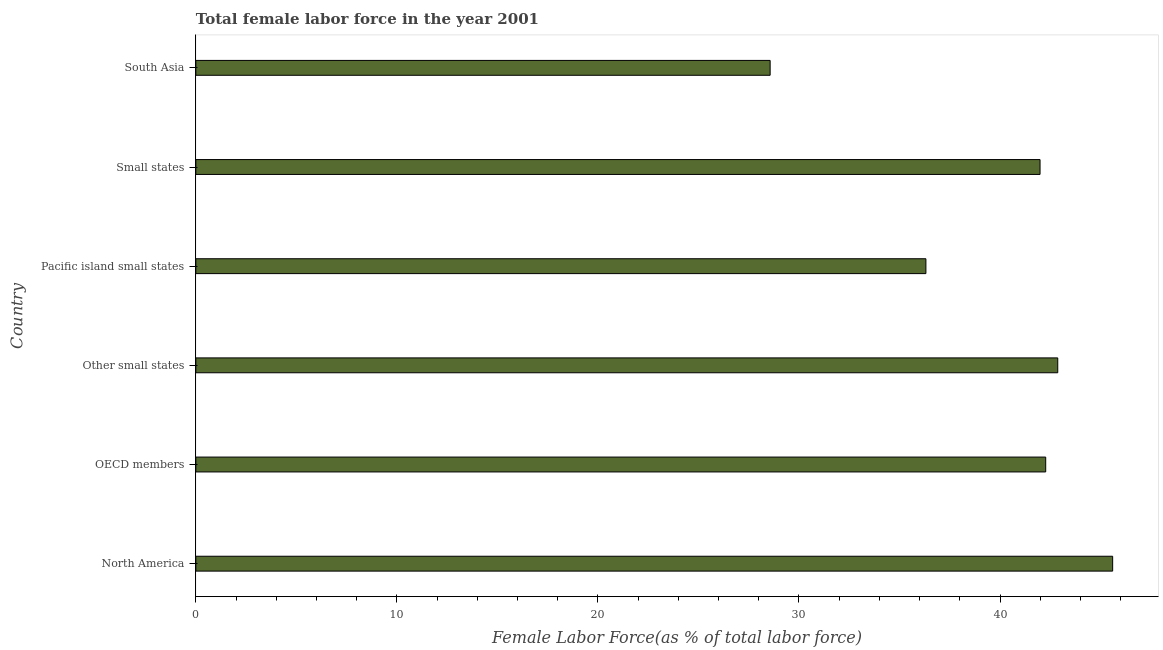Does the graph contain any zero values?
Make the answer very short. No. Does the graph contain grids?
Give a very brief answer. No. What is the title of the graph?
Ensure brevity in your answer.  Total female labor force in the year 2001. What is the label or title of the X-axis?
Offer a terse response. Female Labor Force(as % of total labor force). What is the label or title of the Y-axis?
Offer a terse response. Country. What is the total female labor force in Small states?
Offer a very short reply. 41.99. Across all countries, what is the maximum total female labor force?
Give a very brief answer. 45.6. Across all countries, what is the minimum total female labor force?
Offer a terse response. 28.57. In which country was the total female labor force maximum?
Offer a terse response. North America. What is the sum of the total female labor force?
Offer a very short reply. 237.61. What is the difference between the total female labor force in Other small states and Small states?
Make the answer very short. 0.88. What is the average total female labor force per country?
Make the answer very short. 39.6. What is the median total female labor force?
Your answer should be very brief. 42.13. In how many countries, is the total female labor force greater than 10 %?
Offer a terse response. 6. What is the ratio of the total female labor force in OECD members to that in Pacific island small states?
Provide a succinct answer. 1.16. Is the difference between the total female labor force in Small states and South Asia greater than the difference between any two countries?
Offer a terse response. No. What is the difference between the highest and the second highest total female labor force?
Provide a short and direct response. 2.73. What is the difference between the highest and the lowest total female labor force?
Your response must be concise. 17.04. In how many countries, is the total female labor force greater than the average total female labor force taken over all countries?
Your response must be concise. 4. How many bars are there?
Your answer should be very brief. 6. Are all the bars in the graph horizontal?
Offer a terse response. Yes. What is the difference between two consecutive major ticks on the X-axis?
Your answer should be very brief. 10. What is the Female Labor Force(as % of total labor force) in North America?
Keep it short and to the point. 45.6. What is the Female Labor Force(as % of total labor force) of OECD members?
Provide a short and direct response. 42.27. What is the Female Labor Force(as % of total labor force) of Other small states?
Offer a terse response. 42.87. What is the Female Labor Force(as % of total labor force) of Pacific island small states?
Offer a very short reply. 36.31. What is the Female Labor Force(as % of total labor force) in Small states?
Provide a succinct answer. 41.99. What is the Female Labor Force(as % of total labor force) in South Asia?
Keep it short and to the point. 28.57. What is the difference between the Female Labor Force(as % of total labor force) in North America and OECD members?
Make the answer very short. 3.33. What is the difference between the Female Labor Force(as % of total labor force) in North America and Other small states?
Your response must be concise. 2.73. What is the difference between the Female Labor Force(as % of total labor force) in North America and Pacific island small states?
Make the answer very short. 9.29. What is the difference between the Female Labor Force(as % of total labor force) in North America and Small states?
Your answer should be compact. 3.61. What is the difference between the Female Labor Force(as % of total labor force) in North America and South Asia?
Offer a very short reply. 17.04. What is the difference between the Female Labor Force(as % of total labor force) in OECD members and Other small states?
Offer a very short reply. -0.6. What is the difference between the Female Labor Force(as % of total labor force) in OECD members and Pacific island small states?
Provide a short and direct response. 5.96. What is the difference between the Female Labor Force(as % of total labor force) in OECD members and Small states?
Your answer should be very brief. 0.28. What is the difference between the Female Labor Force(as % of total labor force) in OECD members and South Asia?
Provide a succinct answer. 13.71. What is the difference between the Female Labor Force(as % of total labor force) in Other small states and Pacific island small states?
Make the answer very short. 6.56. What is the difference between the Female Labor Force(as % of total labor force) in Other small states and Small states?
Offer a terse response. 0.88. What is the difference between the Female Labor Force(as % of total labor force) in Other small states and South Asia?
Your answer should be compact. 14.3. What is the difference between the Female Labor Force(as % of total labor force) in Pacific island small states and Small states?
Give a very brief answer. -5.68. What is the difference between the Female Labor Force(as % of total labor force) in Pacific island small states and South Asia?
Give a very brief answer. 7.75. What is the difference between the Female Labor Force(as % of total labor force) in Small states and South Asia?
Give a very brief answer. 13.42. What is the ratio of the Female Labor Force(as % of total labor force) in North America to that in OECD members?
Offer a terse response. 1.08. What is the ratio of the Female Labor Force(as % of total labor force) in North America to that in Other small states?
Make the answer very short. 1.06. What is the ratio of the Female Labor Force(as % of total labor force) in North America to that in Pacific island small states?
Provide a short and direct response. 1.26. What is the ratio of the Female Labor Force(as % of total labor force) in North America to that in Small states?
Your answer should be very brief. 1.09. What is the ratio of the Female Labor Force(as % of total labor force) in North America to that in South Asia?
Your answer should be very brief. 1.6. What is the ratio of the Female Labor Force(as % of total labor force) in OECD members to that in Other small states?
Keep it short and to the point. 0.99. What is the ratio of the Female Labor Force(as % of total labor force) in OECD members to that in Pacific island small states?
Keep it short and to the point. 1.16. What is the ratio of the Female Labor Force(as % of total labor force) in OECD members to that in South Asia?
Keep it short and to the point. 1.48. What is the ratio of the Female Labor Force(as % of total labor force) in Other small states to that in Pacific island small states?
Offer a very short reply. 1.18. What is the ratio of the Female Labor Force(as % of total labor force) in Other small states to that in Small states?
Your answer should be compact. 1.02. What is the ratio of the Female Labor Force(as % of total labor force) in Other small states to that in South Asia?
Ensure brevity in your answer.  1.5. What is the ratio of the Female Labor Force(as % of total labor force) in Pacific island small states to that in Small states?
Your answer should be compact. 0.86. What is the ratio of the Female Labor Force(as % of total labor force) in Pacific island small states to that in South Asia?
Your answer should be compact. 1.27. What is the ratio of the Female Labor Force(as % of total labor force) in Small states to that in South Asia?
Provide a succinct answer. 1.47. 